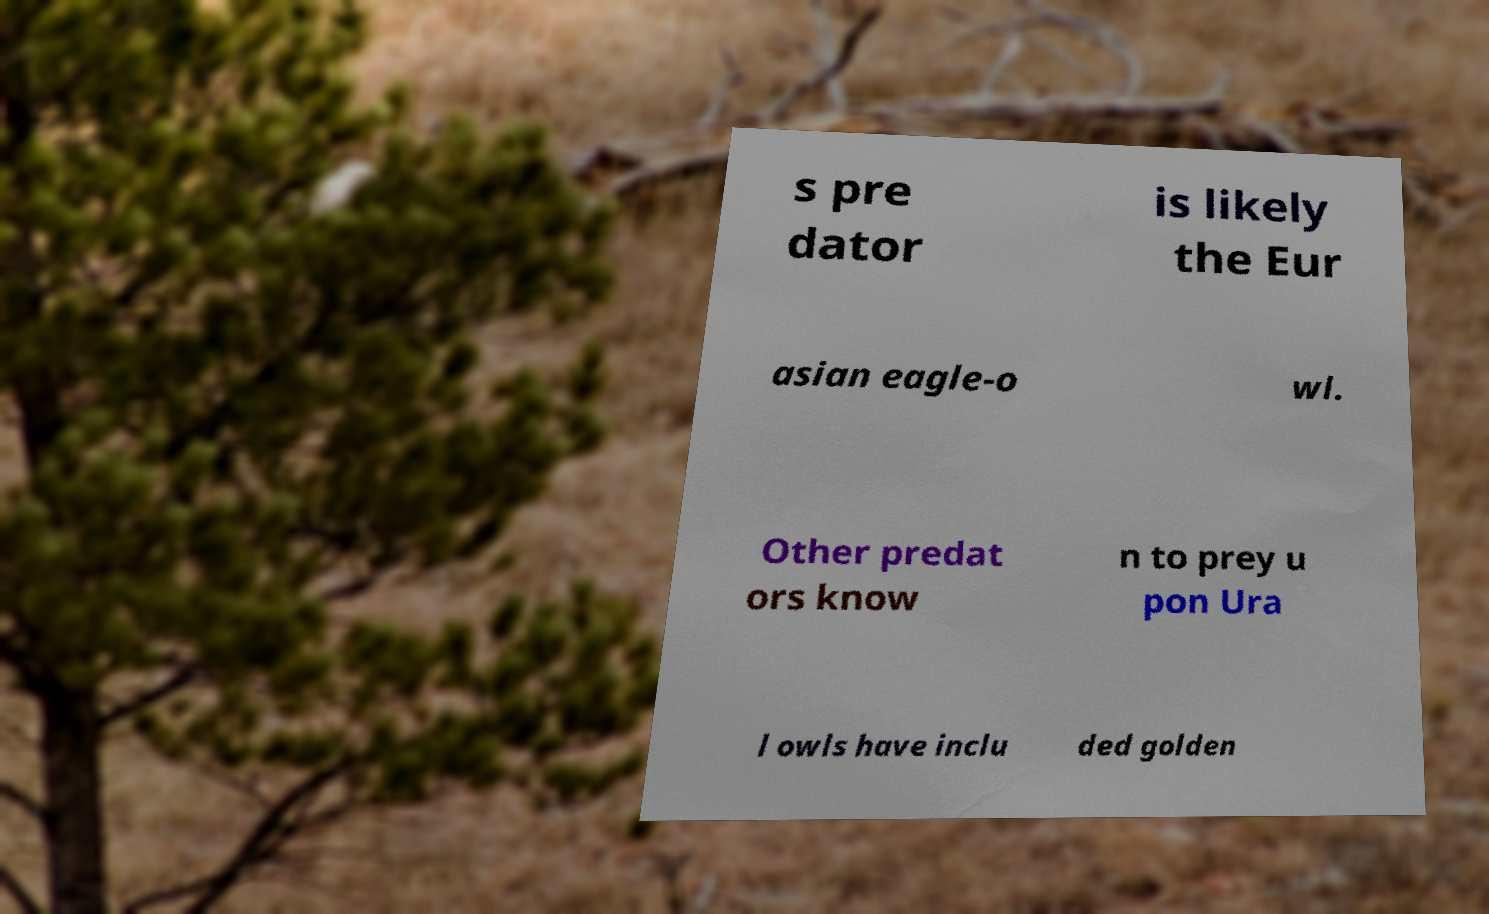Can you accurately transcribe the text from the provided image for me? s pre dator is likely the Eur asian eagle-o wl. Other predat ors know n to prey u pon Ura l owls have inclu ded golden 